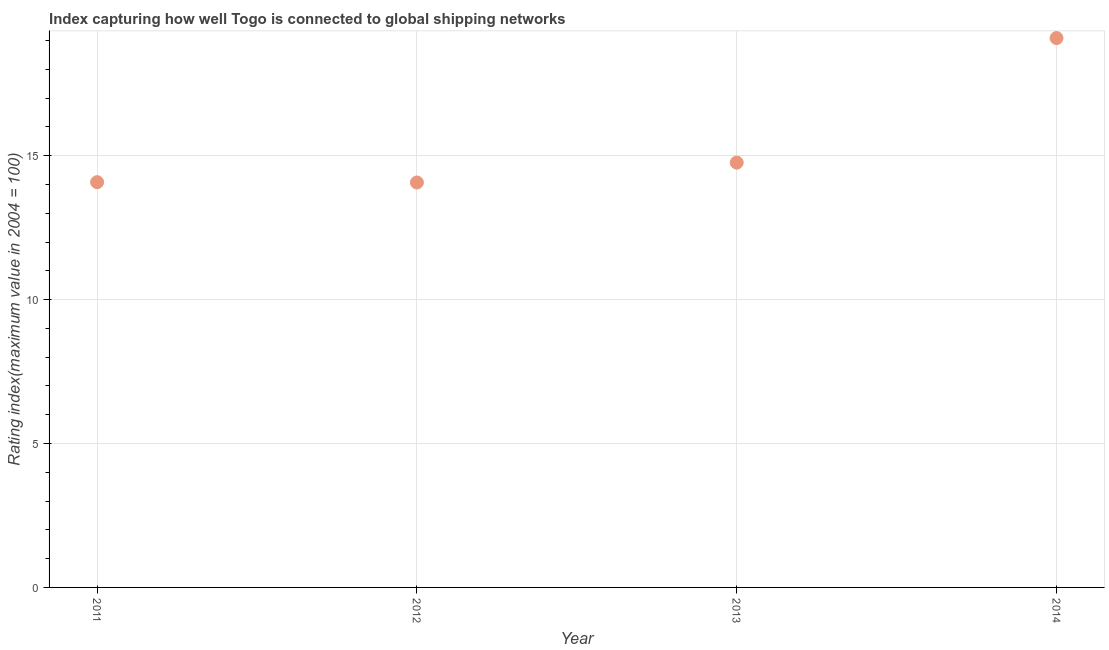What is the liner shipping connectivity index in 2012?
Your response must be concise. 14.07. Across all years, what is the maximum liner shipping connectivity index?
Offer a very short reply. 19.09. Across all years, what is the minimum liner shipping connectivity index?
Keep it short and to the point. 14.07. In which year was the liner shipping connectivity index maximum?
Provide a short and direct response. 2014. What is the sum of the liner shipping connectivity index?
Make the answer very short. 62. What is the difference between the liner shipping connectivity index in 2012 and 2013?
Offer a very short reply. -0.69. What is the average liner shipping connectivity index per year?
Offer a terse response. 15.5. What is the median liner shipping connectivity index?
Ensure brevity in your answer.  14.42. In how many years, is the liner shipping connectivity index greater than 8 ?
Your response must be concise. 4. What is the ratio of the liner shipping connectivity index in 2012 to that in 2014?
Provide a succinct answer. 0.74. Is the difference between the liner shipping connectivity index in 2013 and 2014 greater than the difference between any two years?
Your answer should be compact. No. What is the difference between the highest and the second highest liner shipping connectivity index?
Your answer should be very brief. 4.33. What is the difference between the highest and the lowest liner shipping connectivity index?
Ensure brevity in your answer.  5.02. In how many years, is the liner shipping connectivity index greater than the average liner shipping connectivity index taken over all years?
Make the answer very short. 1. How many years are there in the graph?
Give a very brief answer. 4. Are the values on the major ticks of Y-axis written in scientific E-notation?
Keep it short and to the point. No. What is the title of the graph?
Provide a short and direct response. Index capturing how well Togo is connected to global shipping networks. What is the label or title of the X-axis?
Your response must be concise. Year. What is the label or title of the Y-axis?
Keep it short and to the point. Rating index(maximum value in 2004 = 100). What is the Rating index(maximum value in 2004 = 100) in 2011?
Provide a short and direct response. 14.08. What is the Rating index(maximum value in 2004 = 100) in 2012?
Give a very brief answer. 14.07. What is the Rating index(maximum value in 2004 = 100) in 2013?
Offer a terse response. 14.76. What is the Rating index(maximum value in 2004 = 100) in 2014?
Keep it short and to the point. 19.09. What is the difference between the Rating index(maximum value in 2004 = 100) in 2011 and 2012?
Your answer should be compact. 0.01. What is the difference between the Rating index(maximum value in 2004 = 100) in 2011 and 2013?
Your answer should be very brief. -0.68. What is the difference between the Rating index(maximum value in 2004 = 100) in 2011 and 2014?
Keep it short and to the point. -5.01. What is the difference between the Rating index(maximum value in 2004 = 100) in 2012 and 2013?
Your answer should be compact. -0.69. What is the difference between the Rating index(maximum value in 2004 = 100) in 2012 and 2014?
Your answer should be compact. -5.02. What is the difference between the Rating index(maximum value in 2004 = 100) in 2013 and 2014?
Offer a very short reply. -4.33. What is the ratio of the Rating index(maximum value in 2004 = 100) in 2011 to that in 2013?
Offer a terse response. 0.95. What is the ratio of the Rating index(maximum value in 2004 = 100) in 2011 to that in 2014?
Keep it short and to the point. 0.74. What is the ratio of the Rating index(maximum value in 2004 = 100) in 2012 to that in 2013?
Make the answer very short. 0.95. What is the ratio of the Rating index(maximum value in 2004 = 100) in 2012 to that in 2014?
Offer a very short reply. 0.74. What is the ratio of the Rating index(maximum value in 2004 = 100) in 2013 to that in 2014?
Provide a succinct answer. 0.77. 